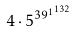Convert formula to latex. <formula><loc_0><loc_0><loc_500><loc_500>4 \cdot 5 ^ { { 3 9 ^ { 1 } } ^ { 1 3 2 } }</formula> 